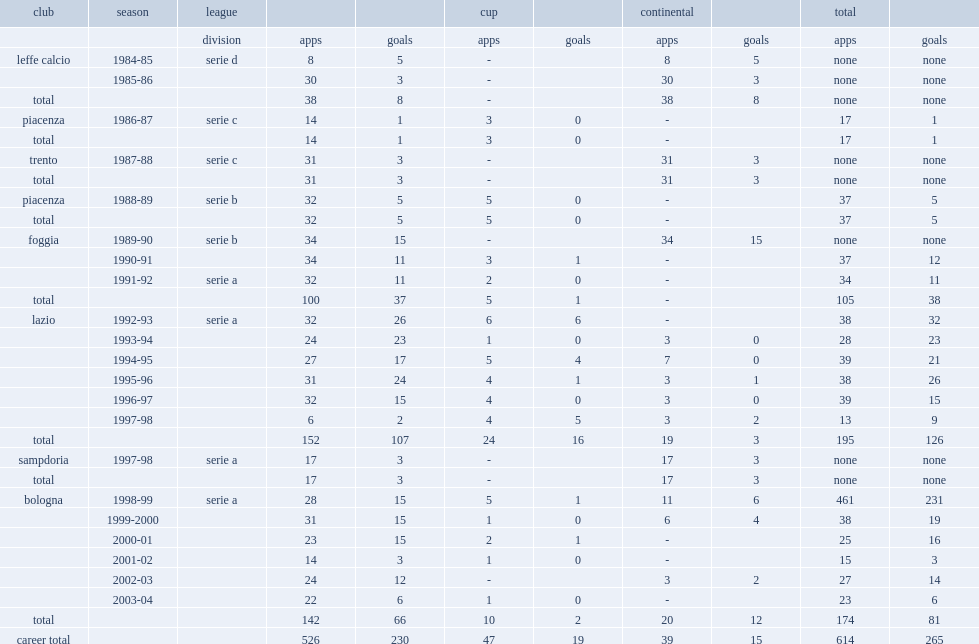Which club did signori play for in 1991-92? Foggia. 